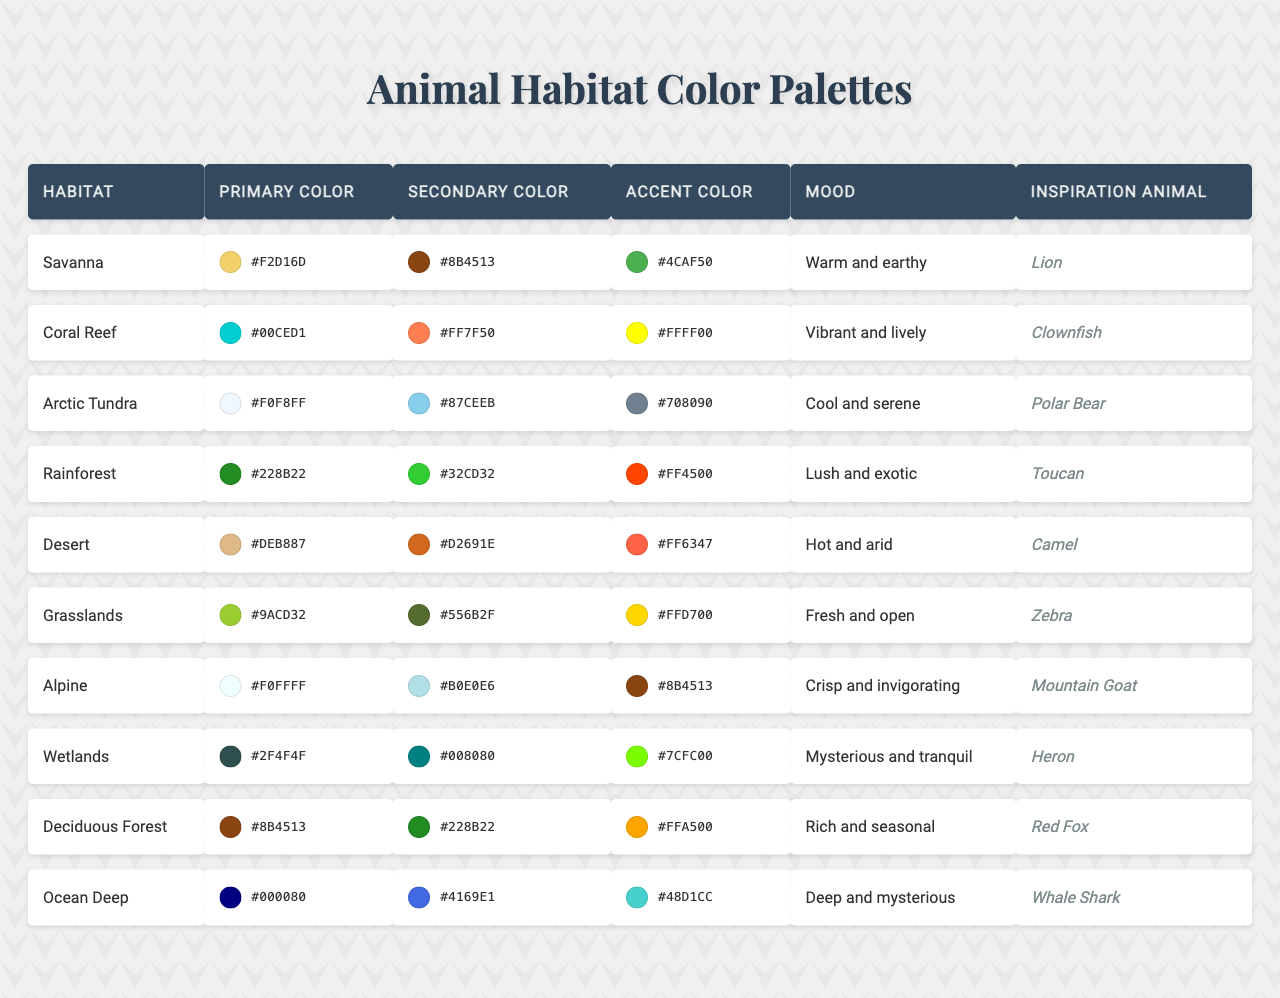What is the primary color associated with the Rainforest habitat? The table indicates that the primary color for the Rainforest habitat is listed in the second column, which is #228B22.
Answer: #228B22 Which habitat has a secondary color of #8B4513? By scanning through the secondary color column, we find that the Desert habitat is associated with the secondary color #8B4513.
Answer: Desert Is the mood of the Arctic Tundra habitat cool and serene? According to the table, the mood listed for the Arctic Tundra habitat is indeed "Cool and serene," which confirms the statement.
Answer: Yes What is the accent color of the Coral Reef habitat? The accent color is found in the fourth column for the Coral Reef habitat, which is noted as #FFFF00.
Answer: #FFFF00 Which habitat’s inspiration animal is the Lion? By looking at the inspiration animal column, it is clear that the Lion is the inspiration animal for the Savanna habitat.
Answer: Savanna How many habitats have a primary color code starting with "#F"? We can count the entries in the primary color column that start with "#F." The habitats are Savanna, Arctic Tundra, Alpine, and Coral Reef, totaling four habitats.
Answer: 4 Is the primary color of the Ocean Deep habitat darker than that of the Deciduous Forest? The primary color for Ocean Deep is #000080 (dark blue), while for Deciduous Forest, it's #8B4513 (brown). Since #000080 is darker than #8B4513, the answer is yes.
Answer: Yes Which habitat has the most vibrant color palette based on mood? To determine this, we need to look at the moods listed in the table. The Coral Reef habitat is described as "Vibrant and lively," which suggests it has the most vibrant color palette.
Answer: Coral Reef If you were to blend the secondary colors of the Grasslands and Desert habitats, would the resulting color be lighter than the primary color of the Savanna habitat? The secondary color of Grasslands is #556B2F and for Desert is #D2691E. Blending these two colors does not produce a lighter color than the Savanna's primary color of #F2D16D, which is a warm light beige. Thus, the answer is no.
Answer: No Among the habitats listed, which one has the accent color that is closest to green? To find this, we compare the accent colors: #FFFF00 (Coral Reef), #708090 (Arctic), #FF4500 (Rainforest), etc. The accent color #7CFC00 from Wetlands is the closest to green.
Answer: Wetlands 